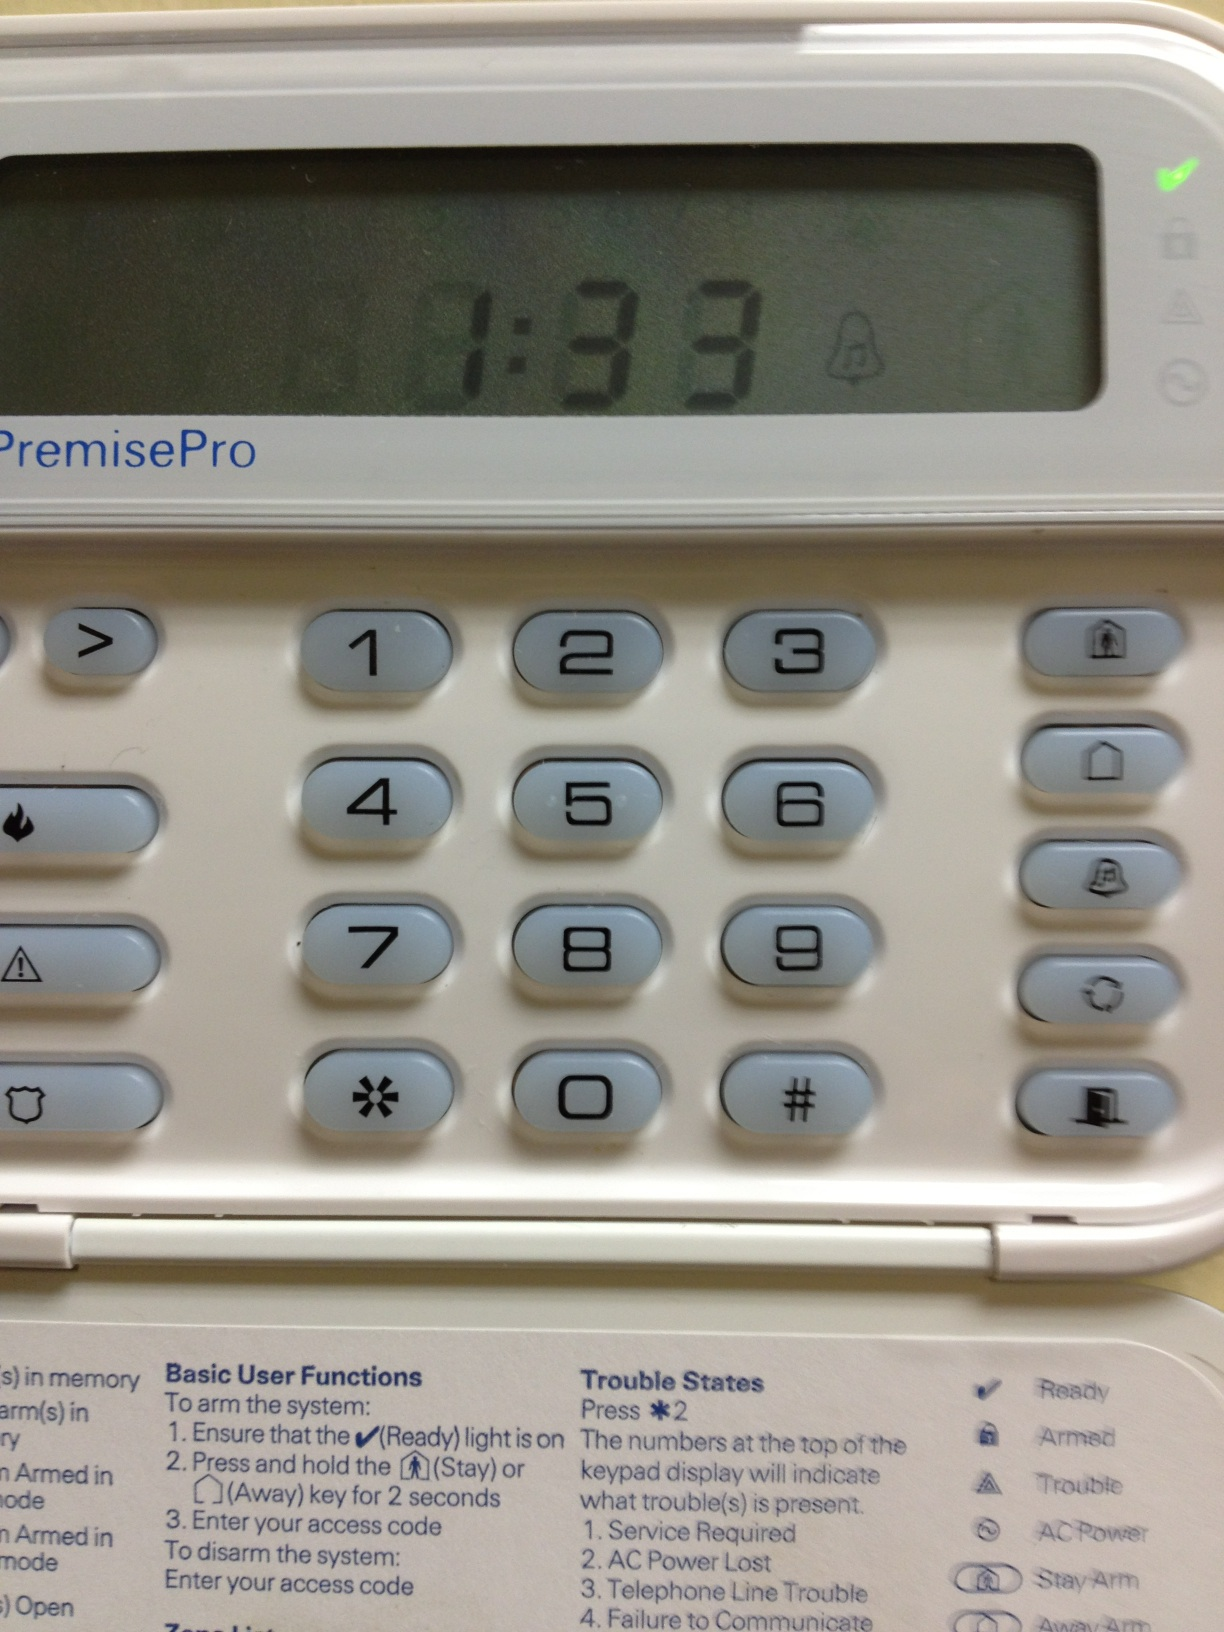How many numbers are on this item? from Vizwiz 10 